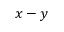<formula> <loc_0><loc_0><loc_500><loc_500>x - y</formula> 